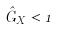Convert formula to latex. <formula><loc_0><loc_0><loc_500><loc_500>\hat { G } _ { X } < 1</formula> 